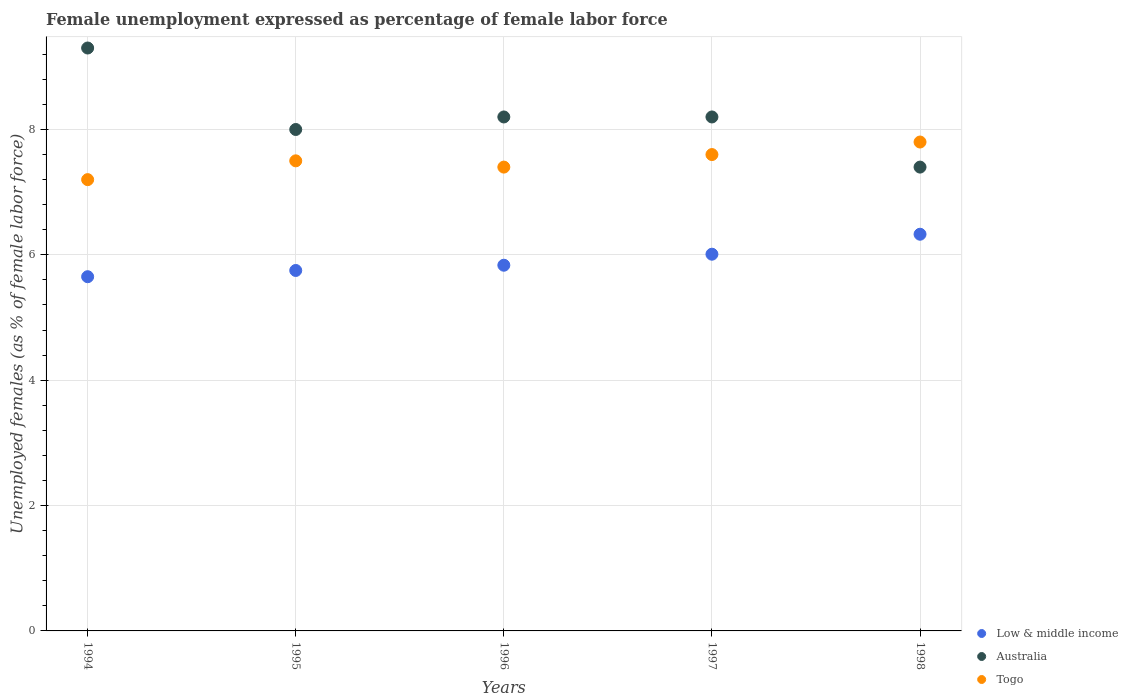Is the number of dotlines equal to the number of legend labels?
Keep it short and to the point. Yes. What is the unemployment in females in in Togo in 1996?
Your answer should be very brief. 7.4. Across all years, what is the maximum unemployment in females in in Low & middle income?
Your response must be concise. 6.33. Across all years, what is the minimum unemployment in females in in Australia?
Provide a succinct answer. 7.4. What is the total unemployment in females in in Australia in the graph?
Your answer should be compact. 41.1. What is the difference between the unemployment in females in in Low & middle income in 1996 and that in 1998?
Provide a short and direct response. -0.49. What is the difference between the unemployment in females in in Australia in 1998 and the unemployment in females in in Togo in 1995?
Provide a short and direct response. -0.1. What is the average unemployment in females in in Low & middle income per year?
Your answer should be compact. 5.92. In the year 1996, what is the difference between the unemployment in females in in Low & middle income and unemployment in females in in Australia?
Provide a short and direct response. -2.37. In how many years, is the unemployment in females in in Togo greater than 8 %?
Your response must be concise. 0. What is the ratio of the unemployment in females in in Togo in 1996 to that in 1997?
Offer a terse response. 0.97. Is the difference between the unemployment in females in in Low & middle income in 1994 and 1995 greater than the difference between the unemployment in females in in Australia in 1994 and 1995?
Your answer should be compact. No. What is the difference between the highest and the second highest unemployment in females in in Togo?
Offer a very short reply. 0.2. What is the difference between the highest and the lowest unemployment in females in in Togo?
Your response must be concise. 0.6. In how many years, is the unemployment in females in in Togo greater than the average unemployment in females in in Togo taken over all years?
Offer a very short reply. 2. Is it the case that in every year, the sum of the unemployment in females in in Low & middle income and unemployment in females in in Australia  is greater than the unemployment in females in in Togo?
Your response must be concise. Yes. Does the unemployment in females in in Australia monotonically increase over the years?
Provide a short and direct response. No. Is the unemployment in females in in Low & middle income strictly greater than the unemployment in females in in Australia over the years?
Provide a succinct answer. No. How many years are there in the graph?
Offer a very short reply. 5. Are the values on the major ticks of Y-axis written in scientific E-notation?
Offer a terse response. No. Where does the legend appear in the graph?
Provide a succinct answer. Bottom right. How many legend labels are there?
Give a very brief answer. 3. What is the title of the graph?
Your answer should be very brief. Female unemployment expressed as percentage of female labor force. What is the label or title of the Y-axis?
Your answer should be very brief. Unemployed females (as % of female labor force). What is the Unemployed females (as % of female labor force) in Low & middle income in 1994?
Your answer should be very brief. 5.65. What is the Unemployed females (as % of female labor force) of Australia in 1994?
Make the answer very short. 9.3. What is the Unemployed females (as % of female labor force) in Togo in 1994?
Provide a short and direct response. 7.2. What is the Unemployed females (as % of female labor force) of Low & middle income in 1995?
Ensure brevity in your answer.  5.75. What is the Unemployed females (as % of female labor force) in Australia in 1995?
Offer a terse response. 8. What is the Unemployed females (as % of female labor force) in Low & middle income in 1996?
Your response must be concise. 5.83. What is the Unemployed females (as % of female labor force) in Australia in 1996?
Provide a short and direct response. 8.2. What is the Unemployed females (as % of female labor force) in Togo in 1996?
Provide a succinct answer. 7.4. What is the Unemployed females (as % of female labor force) in Low & middle income in 1997?
Give a very brief answer. 6.01. What is the Unemployed females (as % of female labor force) in Australia in 1997?
Make the answer very short. 8.2. What is the Unemployed females (as % of female labor force) in Togo in 1997?
Your answer should be very brief. 7.6. What is the Unemployed females (as % of female labor force) in Low & middle income in 1998?
Your answer should be compact. 6.33. What is the Unemployed females (as % of female labor force) of Australia in 1998?
Your answer should be compact. 7.4. What is the Unemployed females (as % of female labor force) in Togo in 1998?
Give a very brief answer. 7.8. Across all years, what is the maximum Unemployed females (as % of female labor force) of Low & middle income?
Keep it short and to the point. 6.33. Across all years, what is the maximum Unemployed females (as % of female labor force) of Australia?
Your answer should be compact. 9.3. Across all years, what is the maximum Unemployed females (as % of female labor force) of Togo?
Provide a succinct answer. 7.8. Across all years, what is the minimum Unemployed females (as % of female labor force) of Low & middle income?
Your answer should be very brief. 5.65. Across all years, what is the minimum Unemployed females (as % of female labor force) in Australia?
Offer a terse response. 7.4. Across all years, what is the minimum Unemployed females (as % of female labor force) in Togo?
Your answer should be compact. 7.2. What is the total Unemployed females (as % of female labor force) of Low & middle income in the graph?
Give a very brief answer. 29.58. What is the total Unemployed females (as % of female labor force) of Australia in the graph?
Ensure brevity in your answer.  41.1. What is the total Unemployed females (as % of female labor force) in Togo in the graph?
Make the answer very short. 37.5. What is the difference between the Unemployed females (as % of female labor force) of Low & middle income in 1994 and that in 1995?
Keep it short and to the point. -0.1. What is the difference between the Unemployed females (as % of female labor force) of Low & middle income in 1994 and that in 1996?
Ensure brevity in your answer.  -0.18. What is the difference between the Unemployed females (as % of female labor force) of Australia in 1994 and that in 1996?
Your answer should be very brief. 1.1. What is the difference between the Unemployed females (as % of female labor force) of Low & middle income in 1994 and that in 1997?
Keep it short and to the point. -0.36. What is the difference between the Unemployed females (as % of female labor force) of Australia in 1994 and that in 1997?
Offer a terse response. 1.1. What is the difference between the Unemployed females (as % of female labor force) of Low & middle income in 1994 and that in 1998?
Your answer should be very brief. -0.68. What is the difference between the Unemployed females (as % of female labor force) of Australia in 1994 and that in 1998?
Your answer should be compact. 1.9. What is the difference between the Unemployed females (as % of female labor force) of Low & middle income in 1995 and that in 1996?
Offer a very short reply. -0.08. What is the difference between the Unemployed females (as % of female labor force) of Australia in 1995 and that in 1996?
Your answer should be compact. -0.2. What is the difference between the Unemployed females (as % of female labor force) of Low & middle income in 1995 and that in 1997?
Keep it short and to the point. -0.26. What is the difference between the Unemployed females (as % of female labor force) in Australia in 1995 and that in 1997?
Make the answer very short. -0.2. What is the difference between the Unemployed females (as % of female labor force) of Low & middle income in 1995 and that in 1998?
Provide a succinct answer. -0.58. What is the difference between the Unemployed females (as % of female labor force) of Australia in 1995 and that in 1998?
Provide a short and direct response. 0.6. What is the difference between the Unemployed females (as % of female labor force) of Low & middle income in 1996 and that in 1997?
Keep it short and to the point. -0.18. What is the difference between the Unemployed females (as % of female labor force) of Australia in 1996 and that in 1997?
Offer a very short reply. 0. What is the difference between the Unemployed females (as % of female labor force) in Low & middle income in 1996 and that in 1998?
Give a very brief answer. -0.49. What is the difference between the Unemployed females (as % of female labor force) in Togo in 1996 and that in 1998?
Your response must be concise. -0.4. What is the difference between the Unemployed females (as % of female labor force) of Low & middle income in 1997 and that in 1998?
Your response must be concise. -0.32. What is the difference between the Unemployed females (as % of female labor force) of Australia in 1997 and that in 1998?
Offer a terse response. 0.8. What is the difference between the Unemployed females (as % of female labor force) in Low & middle income in 1994 and the Unemployed females (as % of female labor force) in Australia in 1995?
Provide a succinct answer. -2.35. What is the difference between the Unemployed females (as % of female labor force) in Low & middle income in 1994 and the Unemployed females (as % of female labor force) in Togo in 1995?
Your answer should be compact. -1.85. What is the difference between the Unemployed females (as % of female labor force) in Low & middle income in 1994 and the Unemployed females (as % of female labor force) in Australia in 1996?
Keep it short and to the point. -2.55. What is the difference between the Unemployed females (as % of female labor force) of Low & middle income in 1994 and the Unemployed females (as % of female labor force) of Togo in 1996?
Offer a terse response. -1.75. What is the difference between the Unemployed females (as % of female labor force) in Low & middle income in 1994 and the Unemployed females (as % of female labor force) in Australia in 1997?
Provide a short and direct response. -2.55. What is the difference between the Unemployed females (as % of female labor force) in Low & middle income in 1994 and the Unemployed females (as % of female labor force) in Togo in 1997?
Give a very brief answer. -1.95. What is the difference between the Unemployed females (as % of female labor force) of Low & middle income in 1994 and the Unemployed females (as % of female labor force) of Australia in 1998?
Give a very brief answer. -1.75. What is the difference between the Unemployed females (as % of female labor force) of Low & middle income in 1994 and the Unemployed females (as % of female labor force) of Togo in 1998?
Your answer should be very brief. -2.15. What is the difference between the Unemployed females (as % of female labor force) in Australia in 1994 and the Unemployed females (as % of female labor force) in Togo in 1998?
Offer a very short reply. 1.5. What is the difference between the Unemployed females (as % of female labor force) of Low & middle income in 1995 and the Unemployed females (as % of female labor force) of Australia in 1996?
Make the answer very short. -2.45. What is the difference between the Unemployed females (as % of female labor force) of Low & middle income in 1995 and the Unemployed females (as % of female labor force) of Togo in 1996?
Your answer should be very brief. -1.65. What is the difference between the Unemployed females (as % of female labor force) of Low & middle income in 1995 and the Unemployed females (as % of female labor force) of Australia in 1997?
Keep it short and to the point. -2.45. What is the difference between the Unemployed females (as % of female labor force) in Low & middle income in 1995 and the Unemployed females (as % of female labor force) in Togo in 1997?
Make the answer very short. -1.85. What is the difference between the Unemployed females (as % of female labor force) of Australia in 1995 and the Unemployed females (as % of female labor force) of Togo in 1997?
Ensure brevity in your answer.  0.4. What is the difference between the Unemployed females (as % of female labor force) in Low & middle income in 1995 and the Unemployed females (as % of female labor force) in Australia in 1998?
Offer a terse response. -1.65. What is the difference between the Unemployed females (as % of female labor force) of Low & middle income in 1995 and the Unemployed females (as % of female labor force) of Togo in 1998?
Keep it short and to the point. -2.05. What is the difference between the Unemployed females (as % of female labor force) in Low & middle income in 1996 and the Unemployed females (as % of female labor force) in Australia in 1997?
Provide a succinct answer. -2.37. What is the difference between the Unemployed females (as % of female labor force) of Low & middle income in 1996 and the Unemployed females (as % of female labor force) of Togo in 1997?
Make the answer very short. -1.77. What is the difference between the Unemployed females (as % of female labor force) of Low & middle income in 1996 and the Unemployed females (as % of female labor force) of Australia in 1998?
Make the answer very short. -1.57. What is the difference between the Unemployed females (as % of female labor force) of Low & middle income in 1996 and the Unemployed females (as % of female labor force) of Togo in 1998?
Offer a terse response. -1.97. What is the difference between the Unemployed females (as % of female labor force) of Low & middle income in 1997 and the Unemployed females (as % of female labor force) of Australia in 1998?
Your answer should be compact. -1.39. What is the difference between the Unemployed females (as % of female labor force) in Low & middle income in 1997 and the Unemployed females (as % of female labor force) in Togo in 1998?
Ensure brevity in your answer.  -1.79. What is the average Unemployed females (as % of female labor force) of Low & middle income per year?
Offer a very short reply. 5.92. What is the average Unemployed females (as % of female labor force) in Australia per year?
Ensure brevity in your answer.  8.22. In the year 1994, what is the difference between the Unemployed females (as % of female labor force) in Low & middle income and Unemployed females (as % of female labor force) in Australia?
Provide a succinct answer. -3.65. In the year 1994, what is the difference between the Unemployed females (as % of female labor force) in Low & middle income and Unemployed females (as % of female labor force) in Togo?
Offer a very short reply. -1.55. In the year 1994, what is the difference between the Unemployed females (as % of female labor force) of Australia and Unemployed females (as % of female labor force) of Togo?
Your answer should be compact. 2.1. In the year 1995, what is the difference between the Unemployed females (as % of female labor force) of Low & middle income and Unemployed females (as % of female labor force) of Australia?
Offer a terse response. -2.25. In the year 1995, what is the difference between the Unemployed females (as % of female labor force) in Low & middle income and Unemployed females (as % of female labor force) in Togo?
Give a very brief answer. -1.75. In the year 1995, what is the difference between the Unemployed females (as % of female labor force) in Australia and Unemployed females (as % of female labor force) in Togo?
Keep it short and to the point. 0.5. In the year 1996, what is the difference between the Unemployed females (as % of female labor force) in Low & middle income and Unemployed females (as % of female labor force) in Australia?
Your response must be concise. -2.37. In the year 1996, what is the difference between the Unemployed females (as % of female labor force) of Low & middle income and Unemployed females (as % of female labor force) of Togo?
Your answer should be compact. -1.57. In the year 1997, what is the difference between the Unemployed females (as % of female labor force) in Low & middle income and Unemployed females (as % of female labor force) in Australia?
Keep it short and to the point. -2.19. In the year 1997, what is the difference between the Unemployed females (as % of female labor force) of Low & middle income and Unemployed females (as % of female labor force) of Togo?
Give a very brief answer. -1.59. In the year 1997, what is the difference between the Unemployed females (as % of female labor force) of Australia and Unemployed females (as % of female labor force) of Togo?
Your answer should be compact. 0.6. In the year 1998, what is the difference between the Unemployed females (as % of female labor force) of Low & middle income and Unemployed females (as % of female labor force) of Australia?
Your answer should be compact. -1.07. In the year 1998, what is the difference between the Unemployed females (as % of female labor force) of Low & middle income and Unemployed females (as % of female labor force) of Togo?
Give a very brief answer. -1.47. What is the ratio of the Unemployed females (as % of female labor force) of Low & middle income in 1994 to that in 1995?
Provide a succinct answer. 0.98. What is the ratio of the Unemployed females (as % of female labor force) of Australia in 1994 to that in 1995?
Keep it short and to the point. 1.16. What is the ratio of the Unemployed females (as % of female labor force) in Low & middle income in 1994 to that in 1996?
Provide a short and direct response. 0.97. What is the ratio of the Unemployed females (as % of female labor force) in Australia in 1994 to that in 1996?
Offer a terse response. 1.13. What is the ratio of the Unemployed females (as % of female labor force) in Low & middle income in 1994 to that in 1997?
Your response must be concise. 0.94. What is the ratio of the Unemployed females (as % of female labor force) of Australia in 1994 to that in 1997?
Ensure brevity in your answer.  1.13. What is the ratio of the Unemployed females (as % of female labor force) in Togo in 1994 to that in 1997?
Keep it short and to the point. 0.95. What is the ratio of the Unemployed females (as % of female labor force) in Low & middle income in 1994 to that in 1998?
Keep it short and to the point. 0.89. What is the ratio of the Unemployed females (as % of female labor force) in Australia in 1994 to that in 1998?
Offer a very short reply. 1.26. What is the ratio of the Unemployed females (as % of female labor force) of Low & middle income in 1995 to that in 1996?
Give a very brief answer. 0.99. What is the ratio of the Unemployed females (as % of female labor force) of Australia in 1995 to that in 1996?
Offer a terse response. 0.98. What is the ratio of the Unemployed females (as % of female labor force) of Togo in 1995 to that in 1996?
Your answer should be compact. 1.01. What is the ratio of the Unemployed females (as % of female labor force) in Low & middle income in 1995 to that in 1997?
Your response must be concise. 0.96. What is the ratio of the Unemployed females (as % of female labor force) in Australia in 1995 to that in 1997?
Keep it short and to the point. 0.98. What is the ratio of the Unemployed females (as % of female labor force) of Low & middle income in 1995 to that in 1998?
Ensure brevity in your answer.  0.91. What is the ratio of the Unemployed females (as % of female labor force) in Australia in 1995 to that in 1998?
Ensure brevity in your answer.  1.08. What is the ratio of the Unemployed females (as % of female labor force) in Togo in 1995 to that in 1998?
Give a very brief answer. 0.96. What is the ratio of the Unemployed females (as % of female labor force) in Low & middle income in 1996 to that in 1997?
Give a very brief answer. 0.97. What is the ratio of the Unemployed females (as % of female labor force) of Togo in 1996 to that in 1997?
Provide a succinct answer. 0.97. What is the ratio of the Unemployed females (as % of female labor force) in Low & middle income in 1996 to that in 1998?
Provide a succinct answer. 0.92. What is the ratio of the Unemployed females (as % of female labor force) of Australia in 1996 to that in 1998?
Ensure brevity in your answer.  1.11. What is the ratio of the Unemployed females (as % of female labor force) in Togo in 1996 to that in 1998?
Provide a succinct answer. 0.95. What is the ratio of the Unemployed females (as % of female labor force) of Low & middle income in 1997 to that in 1998?
Give a very brief answer. 0.95. What is the ratio of the Unemployed females (as % of female labor force) in Australia in 1997 to that in 1998?
Your answer should be compact. 1.11. What is the ratio of the Unemployed females (as % of female labor force) of Togo in 1997 to that in 1998?
Your response must be concise. 0.97. What is the difference between the highest and the second highest Unemployed females (as % of female labor force) in Low & middle income?
Provide a succinct answer. 0.32. What is the difference between the highest and the lowest Unemployed females (as % of female labor force) of Low & middle income?
Your answer should be compact. 0.68. What is the difference between the highest and the lowest Unemployed females (as % of female labor force) of Togo?
Your answer should be very brief. 0.6. 